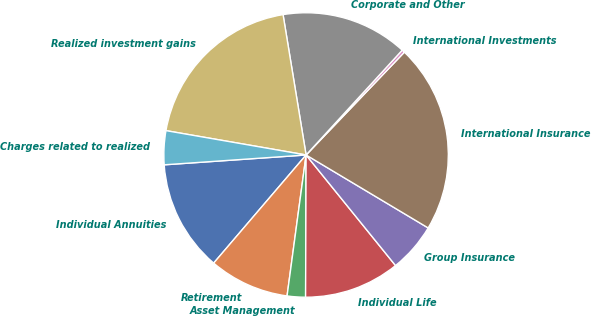Convert chart to OTSL. <chart><loc_0><loc_0><loc_500><loc_500><pie_chart><fcel>Individual Annuities<fcel>Retirement<fcel>Asset Management<fcel>Individual Life<fcel>Group Insurance<fcel>International Insurance<fcel>International Investments<fcel>Corporate and Other<fcel>Realized investment gains<fcel>Charges related to realized<nl><fcel>12.64%<fcel>9.12%<fcel>2.08%<fcel>10.88%<fcel>5.6%<fcel>21.43%<fcel>0.33%<fcel>14.4%<fcel>19.67%<fcel>3.84%<nl></chart> 